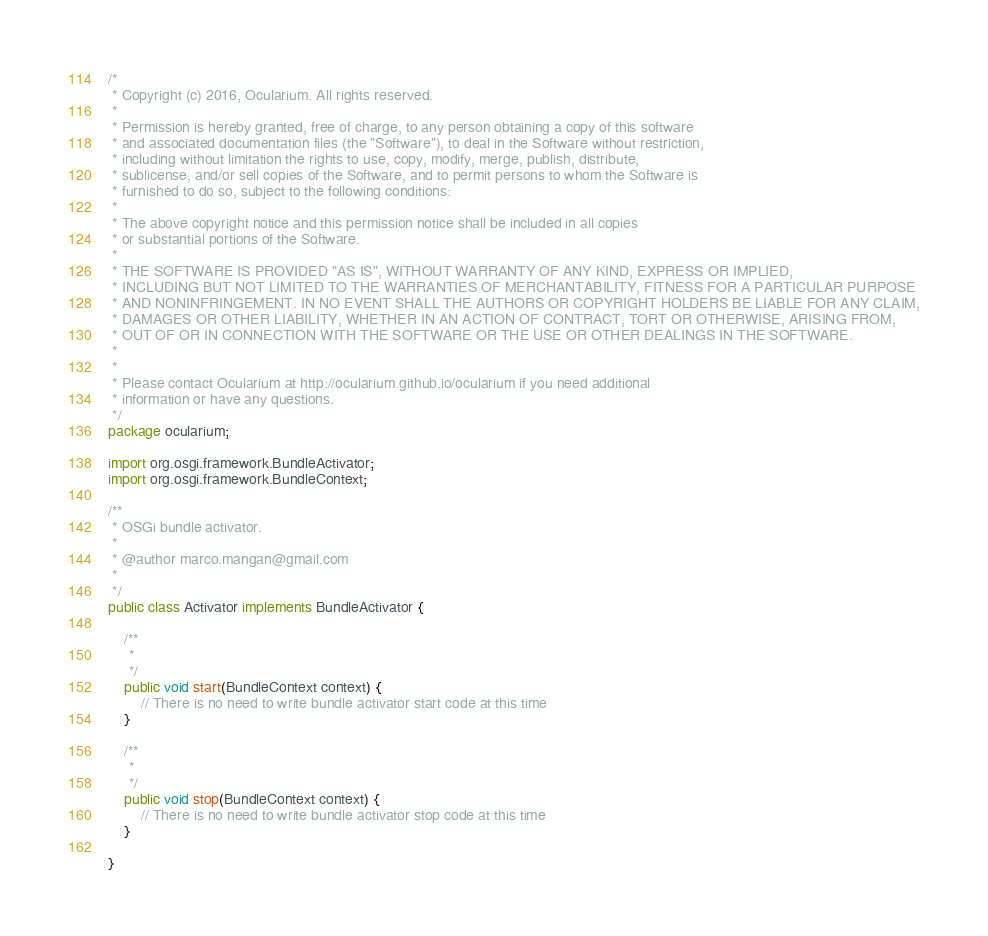Convert code to text. <code><loc_0><loc_0><loc_500><loc_500><_Java_>/*
 * Copyright (c) 2016, Ocularium. All rights reserved.
 *
 * Permission is hereby granted, free of charge, to any person obtaining a copy of this software 
 * and associated documentation files (the "Software"), to deal in the Software without restriction, 
 * including without limitation the rights to use, copy, modify, merge, publish, distribute, 
 * sublicense, and/or sell copies of the Software, and to permit persons to whom the Software is 
 * furnished to do so, subject to the following conditions:
 *
 * The above copyright notice and this permission notice shall be included in all copies 
 * or substantial portions of the Software.
 *
 * THE SOFTWARE IS PROVIDED "AS IS", WITHOUT WARRANTY OF ANY KIND, EXPRESS OR IMPLIED, 
 * INCLUDING BUT NOT LIMITED TO THE WARRANTIES OF MERCHANTABILITY, FITNESS FOR A PARTICULAR PURPOSE 
 * AND NONINFRINGEMENT. IN NO EVENT SHALL THE AUTHORS OR COPYRIGHT HOLDERS BE LIABLE FOR ANY CLAIM,
 * DAMAGES OR OTHER LIABILITY, WHETHER IN AN ACTION OF CONTRACT, TORT OR OTHERWISE, ARISING FROM, 
 * OUT OF OR IN CONNECTION WITH THE SOFTWARE OR THE USE OR OTHER DEALINGS IN THE SOFTWARE.
 *
 *
 * Please contact Ocularium at http://ocularium.github.io/ocularium if you need additional 
 * information or have any questions.
 */
package ocularium;

import org.osgi.framework.BundleActivator;
import org.osgi.framework.BundleContext;

/**
 * OSGi bundle activator.
 * 
 * @author marco.mangan@gmail.com
 *
 */
public class Activator implements BundleActivator {

	/**
	 * 
	 */
	public void start(BundleContext context) {
		// There is no need to write bundle activator start code at this time
	}

	/**
	 * 
	 */
	public void stop(BundleContext context) {
		// There is no need to write bundle activator stop code at this time		
	}

}
</code> 